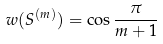Convert formula to latex. <formula><loc_0><loc_0><loc_500><loc_500>w ( S ^ { ( m ) } ) = \cos \frac { \pi } { m + 1 }</formula> 